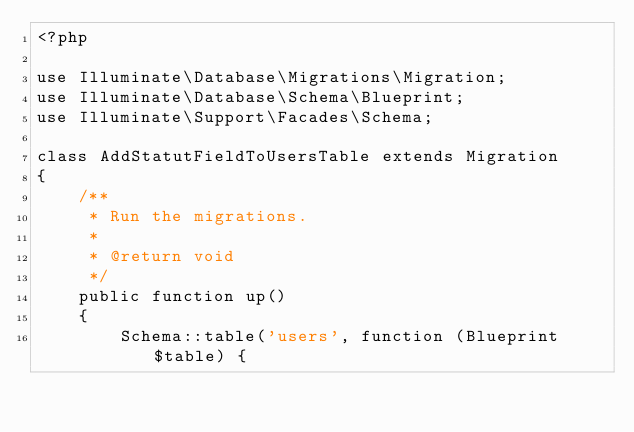Convert code to text. <code><loc_0><loc_0><loc_500><loc_500><_PHP_><?php

use Illuminate\Database\Migrations\Migration;
use Illuminate\Database\Schema\Blueprint;
use Illuminate\Support\Facades\Schema;

class AddStatutFieldToUsersTable extends Migration
{
    /**
     * Run the migrations.
     *
     * @return void
     */
    public function up()
    {
        Schema::table('users', function (Blueprint $table) {
            </code> 